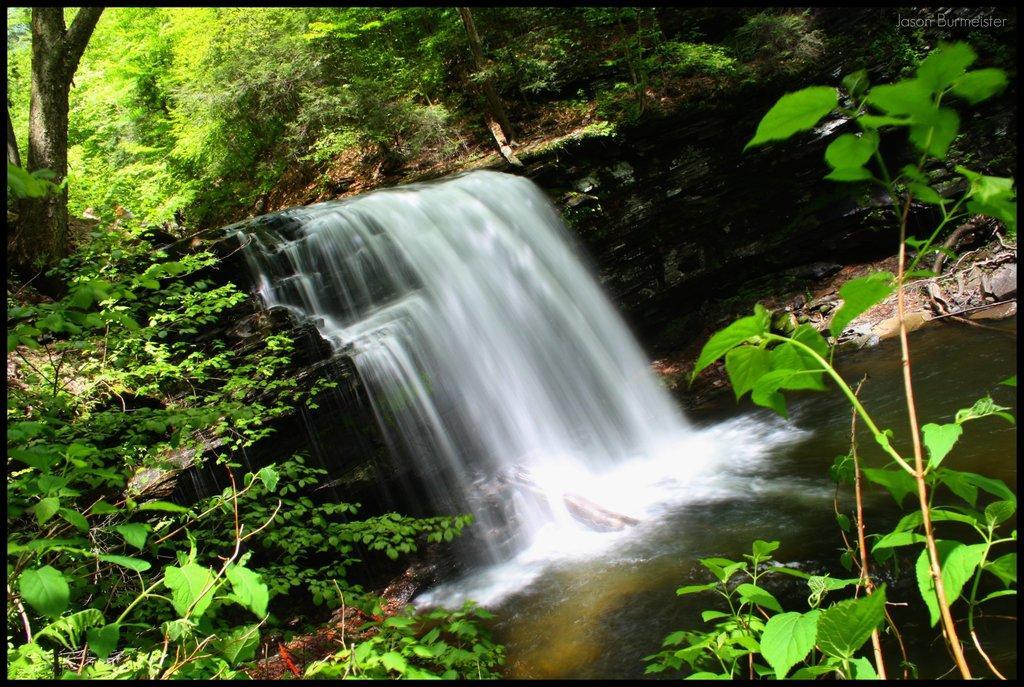Can you describe this image briefly? In the image there is a waterfall in the middle with plants and trees on either side of it. 